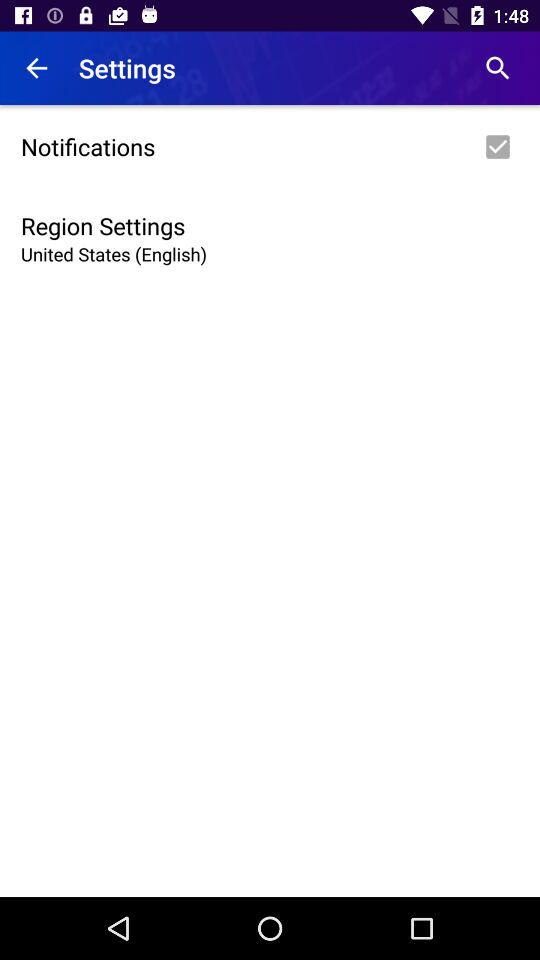Which region is selected? The selected region in the application's settings is the United States, specifically configured for English language. This setting likely affects the app's content display, regional features, and possibly the date and time formats according to local conventions in the United States. 